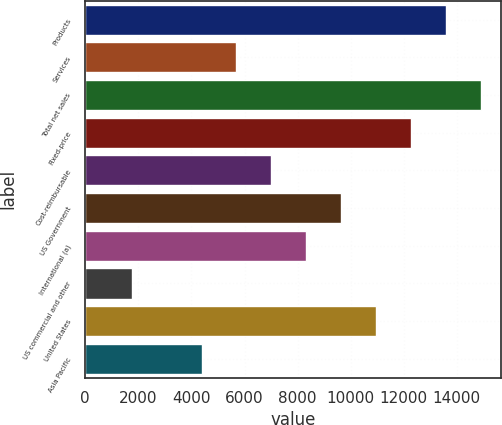<chart> <loc_0><loc_0><loc_500><loc_500><bar_chart><fcel>Products<fcel>Services<fcel>Total net sales<fcel>Fixed-price<fcel>Cost-reimbursable<fcel>US Government<fcel>International (a)<fcel>US commercial and other<fcel>United States<fcel>Asia Pacific<nl><fcel>13595<fcel>5695.4<fcel>14911.6<fcel>12278.4<fcel>7012<fcel>9645.2<fcel>8328.6<fcel>1745.6<fcel>10961.8<fcel>4378.8<nl></chart> 